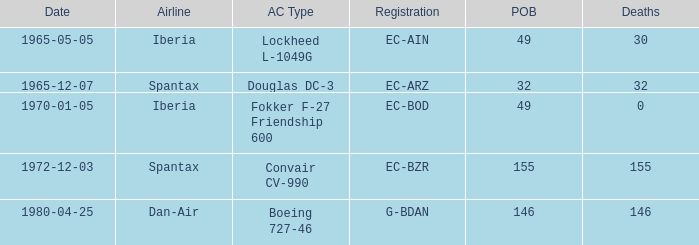How many fatalities shows for the lockheed l-1049g? 30.0. 